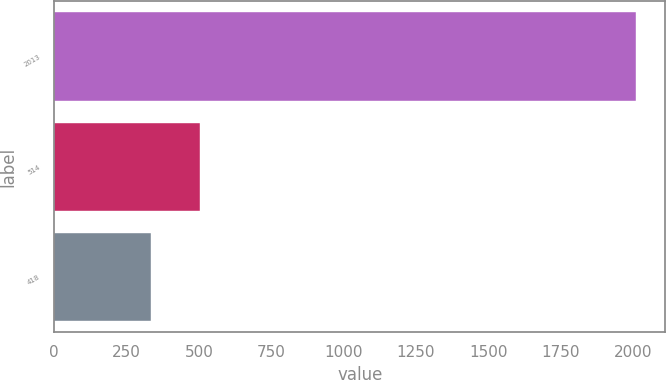<chart> <loc_0><loc_0><loc_500><loc_500><bar_chart><fcel>2013<fcel>514<fcel>418<nl><fcel>2012<fcel>503<fcel>333<nl></chart> 